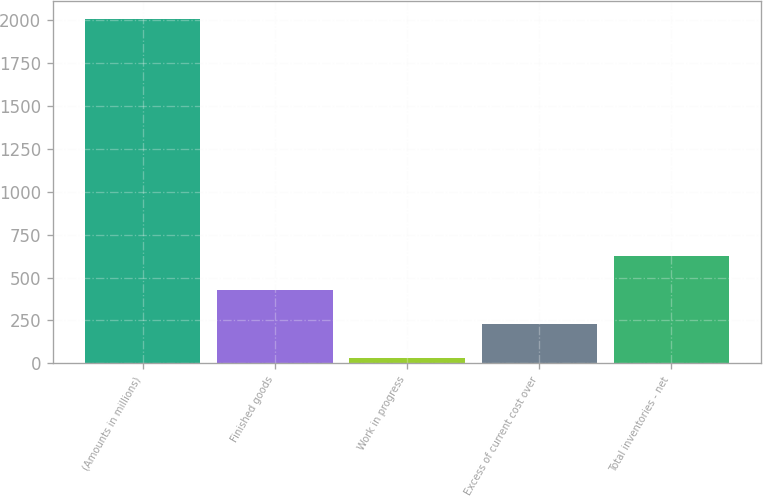Convert chart. <chart><loc_0><loc_0><loc_500><loc_500><bar_chart><fcel>(Amounts in millions)<fcel>Finished goods<fcel>Work in progress<fcel>Excess of current cost over<fcel>Total inventories - net<nl><fcel>2011<fcel>427.96<fcel>32.2<fcel>230.08<fcel>625.84<nl></chart> 